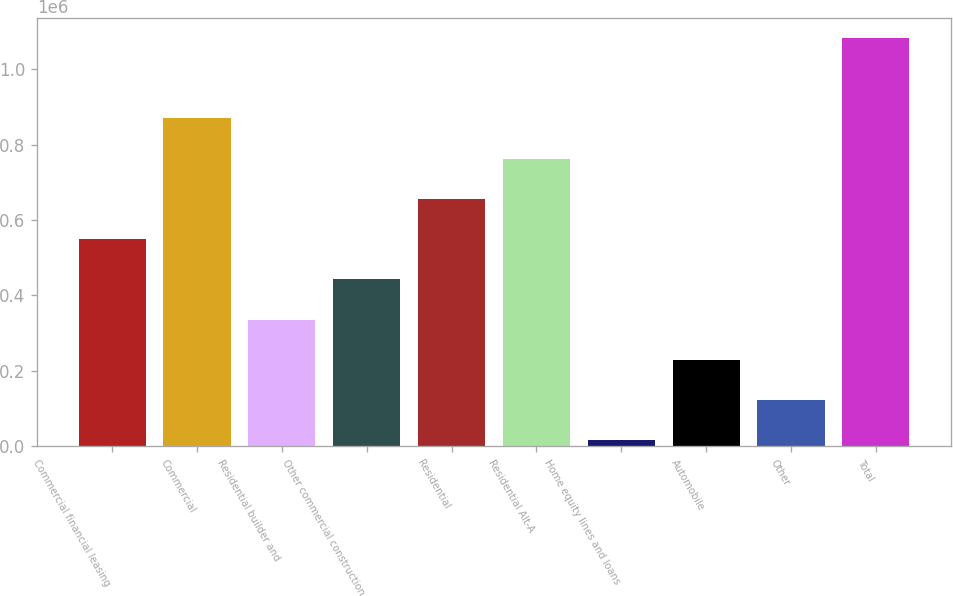Convert chart. <chart><loc_0><loc_0><loc_500><loc_500><bar_chart><fcel>Commercial financial leasing<fcel>Commercial<fcel>Residential builder and<fcel>Other commercial construction<fcel>Residential<fcel>Residential Alt-A<fcel>Home equity lines and loans<fcel>Automobile<fcel>Other<fcel>Total<nl><fcel>549027<fcel>869566<fcel>335335<fcel>442181<fcel>655873<fcel>762719<fcel>14796<fcel>228488<fcel>121642<fcel>1.08326e+06<nl></chart> 